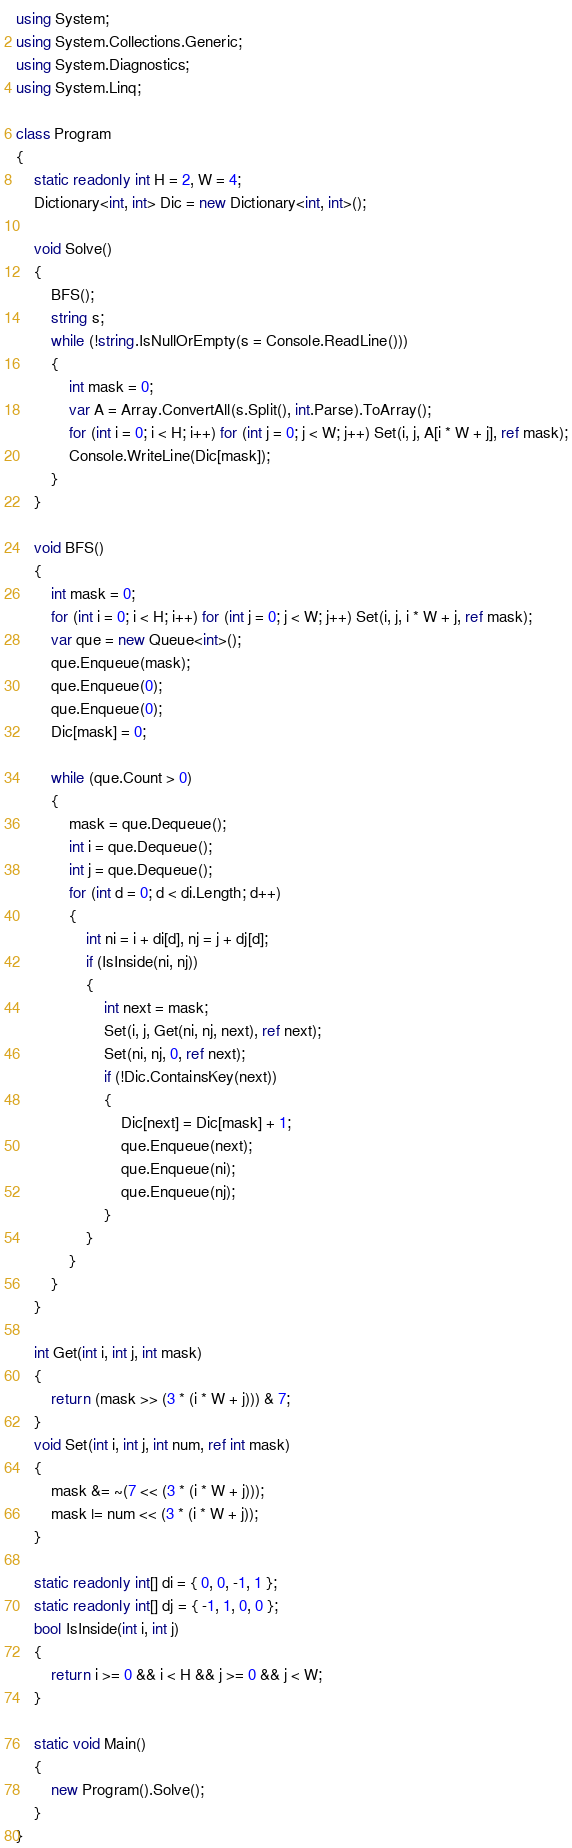<code> <loc_0><loc_0><loc_500><loc_500><_C#_>using System;
using System.Collections.Generic;
using System.Diagnostics;
using System.Linq;

class Program
{
    static readonly int H = 2, W = 4;
    Dictionary<int, int> Dic = new Dictionary<int, int>();

    void Solve()
    {
        BFS();
        string s;
        while (!string.IsNullOrEmpty(s = Console.ReadLine()))
        {
            int mask = 0;
            var A = Array.ConvertAll(s.Split(), int.Parse).ToArray();
            for (int i = 0; i < H; i++) for (int j = 0; j < W; j++) Set(i, j, A[i * W + j], ref mask);
            Console.WriteLine(Dic[mask]);
        }
    }

    void BFS()
    {
        int mask = 0;
        for (int i = 0; i < H; i++) for (int j = 0; j < W; j++) Set(i, j, i * W + j, ref mask);
        var que = new Queue<int>();
        que.Enqueue(mask);
        que.Enqueue(0);
        que.Enqueue(0);
        Dic[mask] = 0;

        while (que.Count > 0)
        {
            mask = que.Dequeue();
            int i = que.Dequeue();
            int j = que.Dequeue();
            for (int d = 0; d < di.Length; d++)
            {
                int ni = i + di[d], nj = j + dj[d];
                if (IsInside(ni, nj))
                {
                    int next = mask;
                    Set(i, j, Get(ni, nj, next), ref next);
                    Set(ni, nj, 0, ref next);
                    if (!Dic.ContainsKey(next))
                    {
                        Dic[next] = Dic[mask] + 1;
                        que.Enqueue(next);
                        que.Enqueue(ni);
                        que.Enqueue(nj);
                    }
                }
            }
        }
    }

    int Get(int i, int j, int mask)
    {
        return (mask >> (3 * (i * W + j))) & 7;
    }
    void Set(int i, int j, int num, ref int mask)
    {
        mask &= ~(7 << (3 * (i * W + j)));
        mask |= num << (3 * (i * W + j));
    }

    static readonly int[] di = { 0, 0, -1, 1 };
    static readonly int[] dj = { -1, 1, 0, 0 };
    bool IsInside(int i, int j)
    {
        return i >= 0 && i < H && j >= 0 && j < W;
    }

    static void Main()
    {
        new Program().Solve();
    }
}</code> 